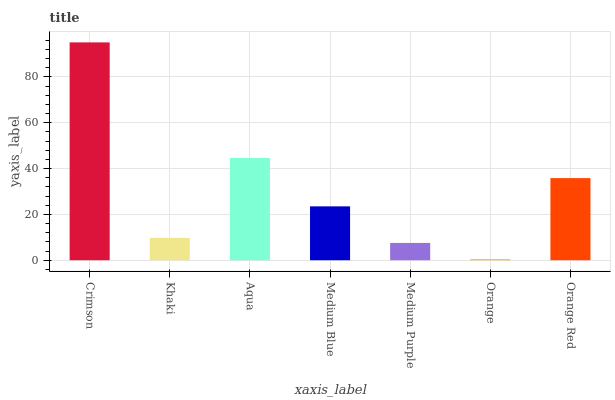Is Orange the minimum?
Answer yes or no. Yes. Is Crimson the maximum?
Answer yes or no. Yes. Is Khaki the minimum?
Answer yes or no. No. Is Khaki the maximum?
Answer yes or no. No. Is Crimson greater than Khaki?
Answer yes or no. Yes. Is Khaki less than Crimson?
Answer yes or no. Yes. Is Khaki greater than Crimson?
Answer yes or no. No. Is Crimson less than Khaki?
Answer yes or no. No. Is Medium Blue the high median?
Answer yes or no. Yes. Is Medium Blue the low median?
Answer yes or no. Yes. Is Orange the high median?
Answer yes or no. No. Is Orange Red the low median?
Answer yes or no. No. 